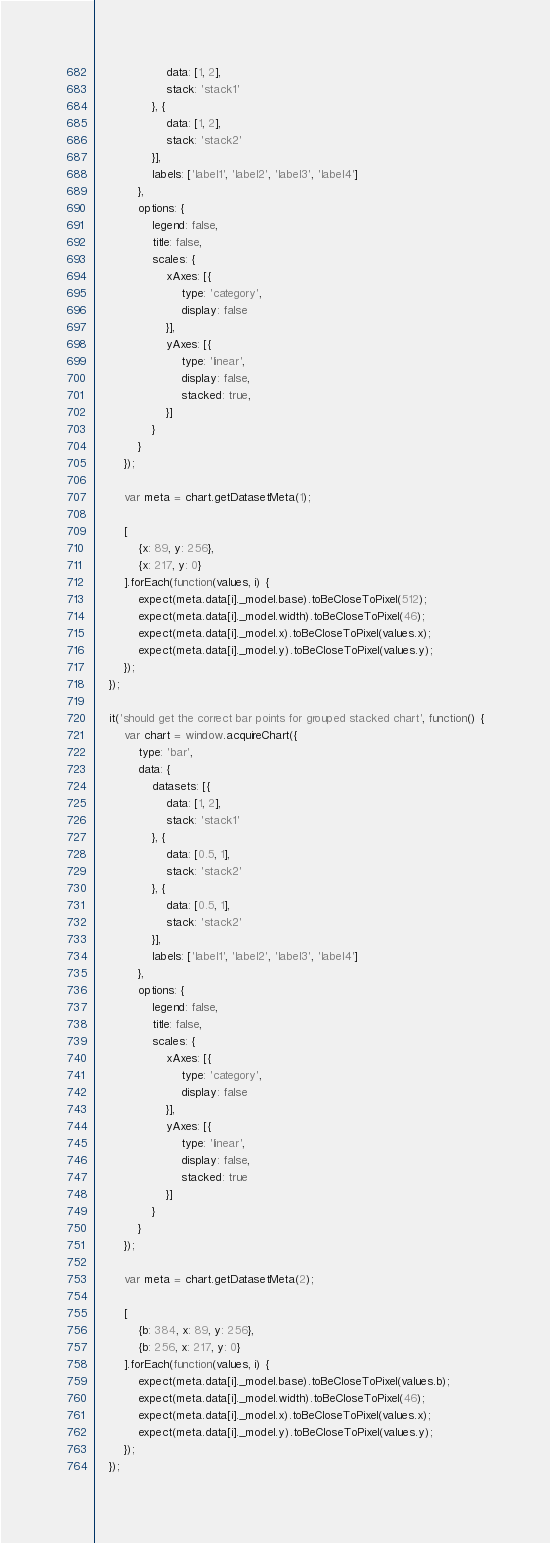<code> <loc_0><loc_0><loc_500><loc_500><_JavaScript_>					data: [1, 2],
					stack: 'stack1'
				}, {
					data: [1, 2],
					stack: 'stack2'
				}],
				labels: ['label1', 'label2', 'label3', 'label4']
			},
			options: {
				legend: false,
				title: false,
				scales: {
					xAxes: [{
						type: 'category',
						display: false
					}],
					yAxes: [{
						type: 'linear',
						display: false,
						stacked: true,
					}]
				}
			}
		});

		var meta = chart.getDatasetMeta(1);

		[
			{x: 89, y: 256},
			{x: 217, y: 0}
		].forEach(function(values, i) {
			expect(meta.data[i]._model.base).toBeCloseToPixel(512);
			expect(meta.data[i]._model.width).toBeCloseToPixel(46);
			expect(meta.data[i]._model.x).toBeCloseToPixel(values.x);
			expect(meta.data[i]._model.y).toBeCloseToPixel(values.y);
		});
	});

	it('should get the correct bar points for grouped stacked chart', function() {
		var chart = window.acquireChart({
			type: 'bar',
			data: {
				datasets: [{
					data: [1, 2],
					stack: 'stack1'
				}, {
					data: [0.5, 1],
					stack: 'stack2'
				}, {
					data: [0.5, 1],
					stack: 'stack2'
				}],
				labels: ['label1', 'label2', 'label3', 'label4']
			},
			options: {
				legend: false,
				title: false,
				scales: {
					xAxes: [{
						type: 'category',
						display: false
					}],
					yAxes: [{
						type: 'linear',
						display: false,
						stacked: true
					}]
				}
			}
		});

		var meta = chart.getDatasetMeta(2);

		[
			{b: 384, x: 89, y: 256},
			{b: 256, x: 217, y: 0}
		].forEach(function(values, i) {
			expect(meta.data[i]._model.base).toBeCloseToPixel(values.b);
			expect(meta.data[i]._model.width).toBeCloseToPixel(46);
			expect(meta.data[i]._model.x).toBeCloseToPixel(values.x);
			expect(meta.data[i]._model.y).toBeCloseToPixel(values.y);
		});
	});
</code> 